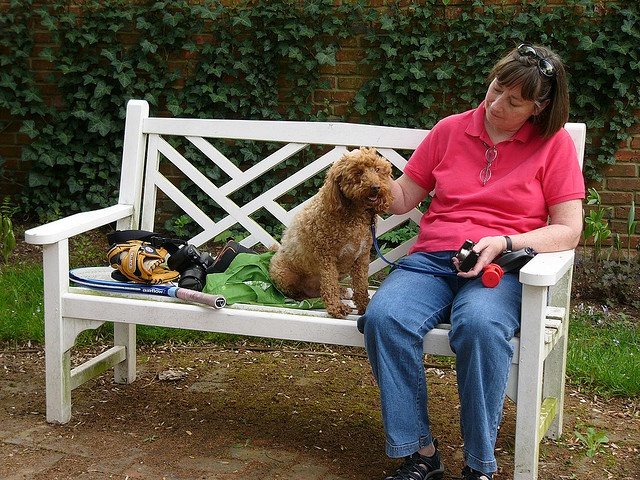Describe the objects in this image and their specific colors. I can see bench in black, lightgray, darkgray, and gray tones, people in black, brown, navy, and blue tones, dog in black, maroon, and gray tones, bench in black, lightgray, darkgray, and gray tones, and tennis racket in black, lightgray, navy, and gray tones in this image. 